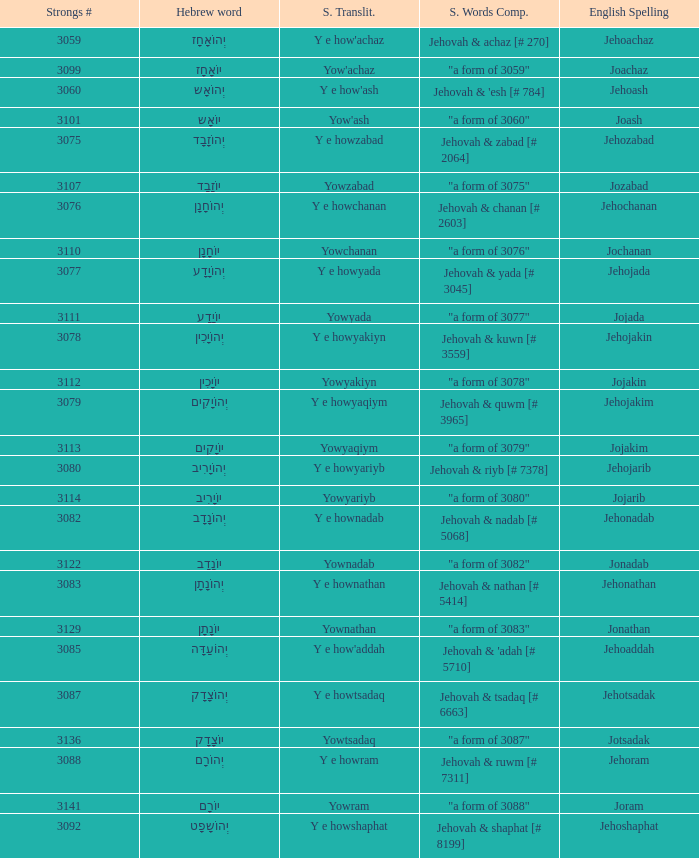What is the english spelling of the word that has the strongs trasliteration of y e howram? Jehoram. 